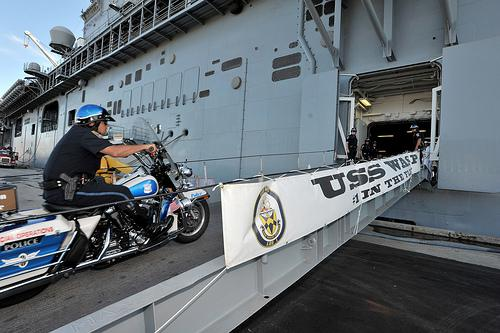Question: what is the police officer riding?
Choices:
A. Horse.
B. Motorcycle.
C. Car.
D. Bike.
Answer with the letter. Answer: B Question: what color is the police officer's uniform?
Choices:
A. Blue.
B. White.
C. Black.
D. Red.
Answer with the letter. Answer: C Question: where is the gun located?
Choices:
A. On right hip.
B. On his back.
C. Under his belt.
D. Under his shirt.
Answer with the letter. Answer: A Question: what is the color of the boat?
Choices:
A. Black.
B. Grey.
C. White.
D. Silver.
Answer with the letter. Answer: B 